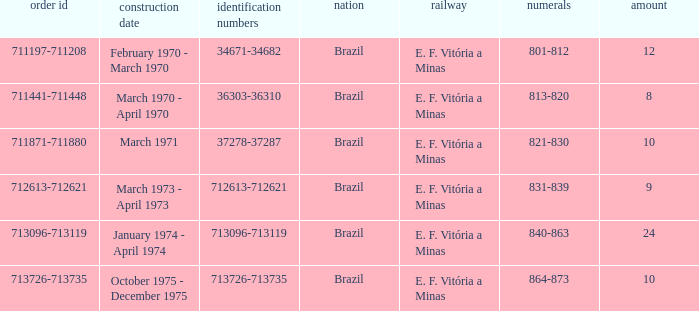What country has the order number 711871-711880? Brazil. 